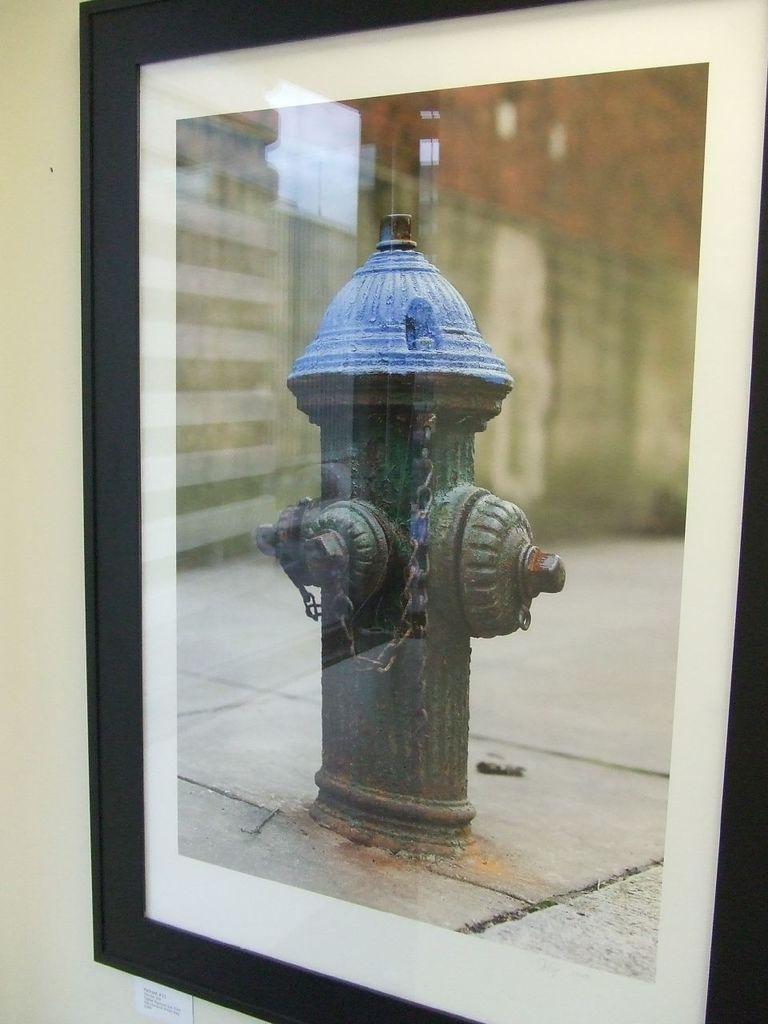Describe this image in one or two sentences. In this image I can see the photo-frame to the wall. In the frame I can see a fire hydrant and the building. 